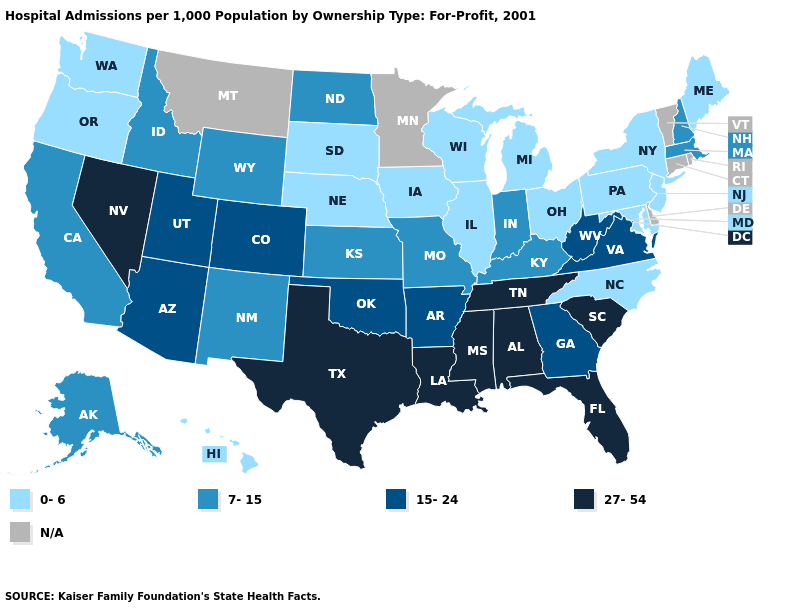How many symbols are there in the legend?
Be succinct. 5. Which states hav the highest value in the MidWest?
Be succinct. Indiana, Kansas, Missouri, North Dakota. What is the value of Nebraska?
Quick response, please. 0-6. Name the states that have a value in the range 27-54?
Quick response, please. Alabama, Florida, Louisiana, Mississippi, Nevada, South Carolina, Tennessee, Texas. Among the states that border Texas , does Arkansas have the highest value?
Quick response, please. No. What is the value of Virginia?
Concise answer only. 15-24. How many symbols are there in the legend?
Short answer required. 5. What is the value of Vermont?
Give a very brief answer. N/A. Name the states that have a value in the range 7-15?
Give a very brief answer. Alaska, California, Idaho, Indiana, Kansas, Kentucky, Massachusetts, Missouri, New Hampshire, New Mexico, North Dakota, Wyoming. What is the highest value in the Northeast ?
Short answer required. 7-15. What is the value of Wisconsin?
Give a very brief answer. 0-6. Does the first symbol in the legend represent the smallest category?
Short answer required. Yes. What is the lowest value in the MidWest?
Short answer required. 0-6. Name the states that have a value in the range 0-6?
Concise answer only. Hawaii, Illinois, Iowa, Maine, Maryland, Michigan, Nebraska, New Jersey, New York, North Carolina, Ohio, Oregon, Pennsylvania, South Dakota, Washington, Wisconsin. 